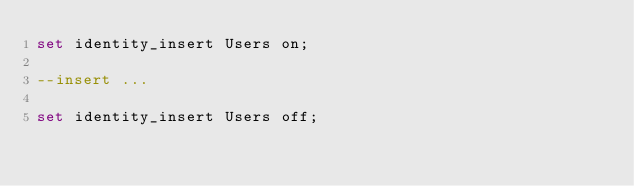<code> <loc_0><loc_0><loc_500><loc_500><_SQL_>set identity_insert Users on;

--insert ...

set identity_insert Users off;</code> 